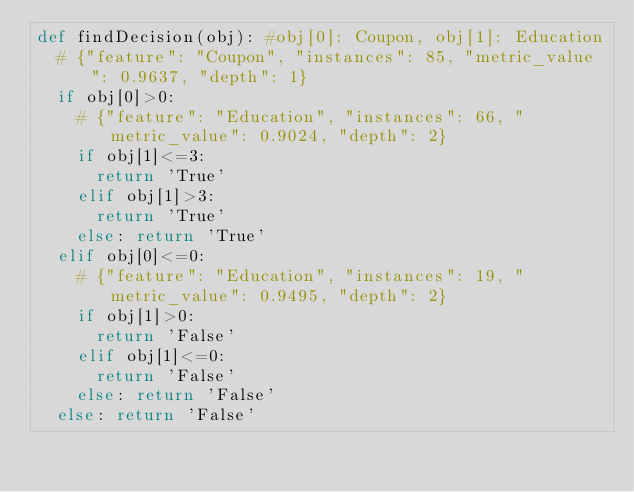<code> <loc_0><loc_0><loc_500><loc_500><_Python_>def findDecision(obj): #obj[0]: Coupon, obj[1]: Education
	# {"feature": "Coupon", "instances": 85, "metric_value": 0.9637, "depth": 1}
	if obj[0]>0:
		# {"feature": "Education", "instances": 66, "metric_value": 0.9024, "depth": 2}
		if obj[1]<=3:
			return 'True'
		elif obj[1]>3:
			return 'True'
		else: return 'True'
	elif obj[0]<=0:
		# {"feature": "Education", "instances": 19, "metric_value": 0.9495, "depth": 2}
		if obj[1]>0:
			return 'False'
		elif obj[1]<=0:
			return 'False'
		else: return 'False'
	else: return 'False'
</code> 